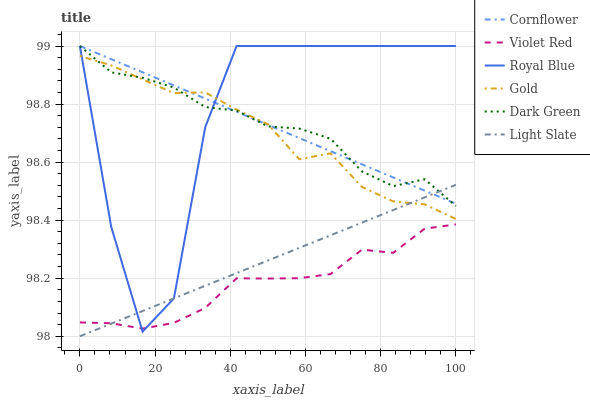Does Violet Red have the minimum area under the curve?
Answer yes or no. Yes. Does Royal Blue have the maximum area under the curve?
Answer yes or no. Yes. Does Gold have the minimum area under the curve?
Answer yes or no. No. Does Gold have the maximum area under the curve?
Answer yes or no. No. Is Light Slate the smoothest?
Answer yes or no. Yes. Is Royal Blue the roughest?
Answer yes or no. Yes. Is Violet Red the smoothest?
Answer yes or no. No. Is Violet Red the roughest?
Answer yes or no. No. Does Violet Red have the lowest value?
Answer yes or no. No. Does Dark Green have the highest value?
Answer yes or no. Yes. Does Gold have the highest value?
Answer yes or no. No. Is Violet Red less than Dark Green?
Answer yes or no. Yes. Is Gold greater than Violet Red?
Answer yes or no. Yes. Does Royal Blue intersect Gold?
Answer yes or no. Yes. Is Royal Blue less than Gold?
Answer yes or no. No. Is Royal Blue greater than Gold?
Answer yes or no. No. Does Violet Red intersect Dark Green?
Answer yes or no. No. 